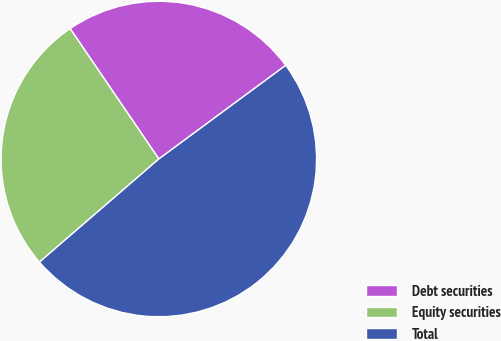Convert chart. <chart><loc_0><loc_0><loc_500><loc_500><pie_chart><fcel>Debt securities<fcel>Equity securities<fcel>Total<nl><fcel>24.39%<fcel>26.83%<fcel>48.78%<nl></chart> 